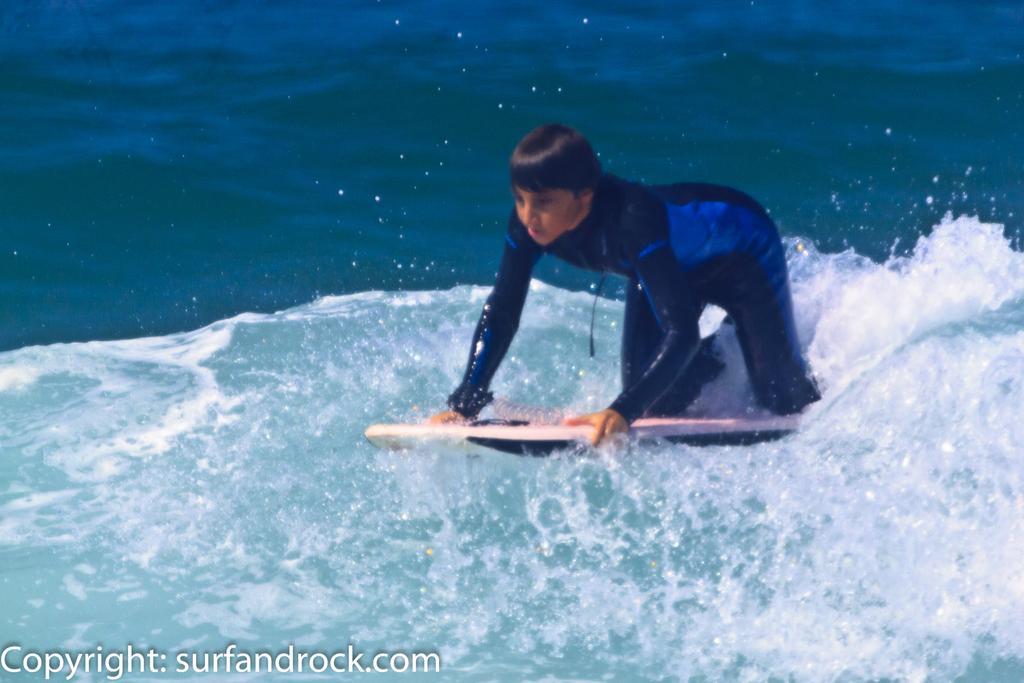Describe this image in one or two sentences. Here we can see a person holding a diving device in his hands and this is a water. 